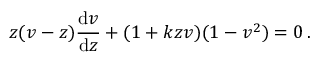Convert formula to latex. <formula><loc_0><loc_0><loc_500><loc_500>z ( v - z ) { \frac { d v } { d z } } + ( 1 + k z v ) ( 1 - v ^ { 2 } ) = 0 \, .</formula> 